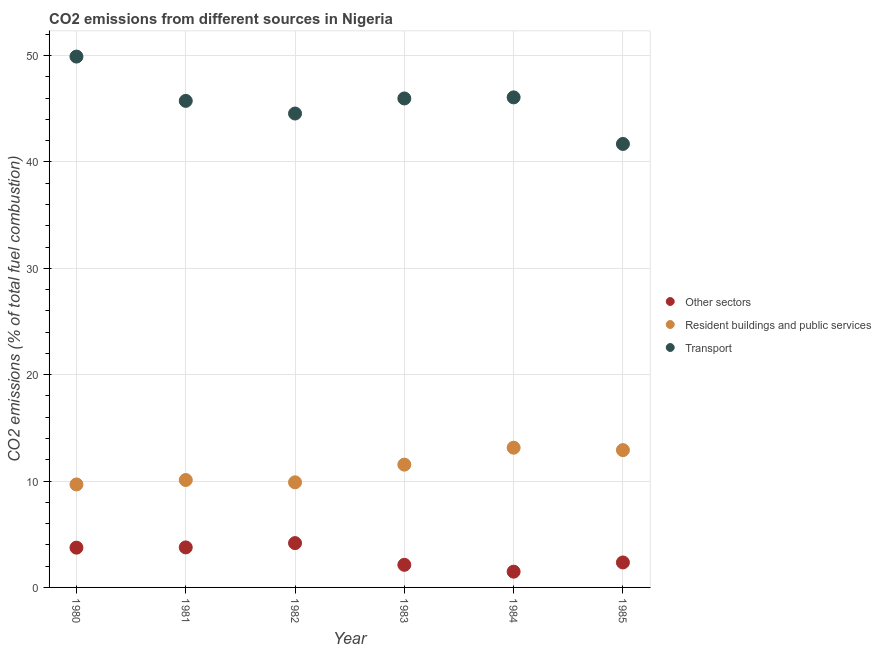How many different coloured dotlines are there?
Ensure brevity in your answer.  3. What is the percentage of co2 emissions from transport in 1980?
Offer a very short reply. 49.91. Across all years, what is the maximum percentage of co2 emissions from resident buildings and public services?
Make the answer very short. 13.14. Across all years, what is the minimum percentage of co2 emissions from resident buildings and public services?
Provide a short and direct response. 9.68. In which year was the percentage of co2 emissions from resident buildings and public services minimum?
Offer a terse response. 1980. What is the total percentage of co2 emissions from resident buildings and public services in the graph?
Give a very brief answer. 67.25. What is the difference between the percentage of co2 emissions from resident buildings and public services in 1982 and that in 1983?
Your answer should be very brief. -1.66. What is the difference between the percentage of co2 emissions from resident buildings and public services in 1982 and the percentage of co2 emissions from transport in 1984?
Provide a short and direct response. -36.19. What is the average percentage of co2 emissions from resident buildings and public services per year?
Provide a succinct answer. 11.21. In the year 1983, what is the difference between the percentage of co2 emissions from transport and percentage of co2 emissions from other sectors?
Keep it short and to the point. 43.84. What is the ratio of the percentage of co2 emissions from resident buildings and public services in 1981 to that in 1983?
Your response must be concise. 0.87. Is the percentage of co2 emissions from resident buildings and public services in 1984 less than that in 1985?
Offer a very short reply. No. Is the difference between the percentage of co2 emissions from transport in 1981 and 1982 greater than the difference between the percentage of co2 emissions from other sectors in 1981 and 1982?
Provide a short and direct response. Yes. What is the difference between the highest and the second highest percentage of co2 emissions from resident buildings and public services?
Your answer should be compact. 0.23. What is the difference between the highest and the lowest percentage of co2 emissions from transport?
Offer a terse response. 8.21. Is the percentage of co2 emissions from resident buildings and public services strictly less than the percentage of co2 emissions from transport over the years?
Your answer should be compact. Yes. How many dotlines are there?
Give a very brief answer. 3. How many years are there in the graph?
Your response must be concise. 6. How are the legend labels stacked?
Ensure brevity in your answer.  Vertical. What is the title of the graph?
Keep it short and to the point. CO2 emissions from different sources in Nigeria. Does "Nuclear sources" appear as one of the legend labels in the graph?
Give a very brief answer. No. What is the label or title of the X-axis?
Give a very brief answer. Year. What is the label or title of the Y-axis?
Make the answer very short. CO2 emissions (% of total fuel combustion). What is the CO2 emissions (% of total fuel combustion) of Other sectors in 1980?
Your answer should be very brief. 3.74. What is the CO2 emissions (% of total fuel combustion) in Resident buildings and public services in 1980?
Provide a short and direct response. 9.68. What is the CO2 emissions (% of total fuel combustion) of Transport in 1980?
Offer a very short reply. 49.91. What is the CO2 emissions (% of total fuel combustion) of Other sectors in 1981?
Your answer should be very brief. 3.76. What is the CO2 emissions (% of total fuel combustion) in Resident buildings and public services in 1981?
Make the answer very short. 10.1. What is the CO2 emissions (% of total fuel combustion) of Transport in 1981?
Provide a succinct answer. 45.74. What is the CO2 emissions (% of total fuel combustion) in Other sectors in 1982?
Keep it short and to the point. 4.17. What is the CO2 emissions (% of total fuel combustion) in Resident buildings and public services in 1982?
Your response must be concise. 9.88. What is the CO2 emissions (% of total fuel combustion) of Transport in 1982?
Offer a very short reply. 44.55. What is the CO2 emissions (% of total fuel combustion) in Other sectors in 1983?
Make the answer very short. 2.13. What is the CO2 emissions (% of total fuel combustion) of Resident buildings and public services in 1983?
Your answer should be very brief. 11.54. What is the CO2 emissions (% of total fuel combustion) of Transport in 1983?
Your answer should be very brief. 45.97. What is the CO2 emissions (% of total fuel combustion) of Other sectors in 1984?
Keep it short and to the point. 1.48. What is the CO2 emissions (% of total fuel combustion) of Resident buildings and public services in 1984?
Keep it short and to the point. 13.14. What is the CO2 emissions (% of total fuel combustion) of Transport in 1984?
Give a very brief answer. 46.07. What is the CO2 emissions (% of total fuel combustion) of Other sectors in 1985?
Your response must be concise. 2.35. What is the CO2 emissions (% of total fuel combustion) in Resident buildings and public services in 1985?
Offer a very short reply. 12.91. What is the CO2 emissions (% of total fuel combustion) of Transport in 1985?
Your answer should be very brief. 41.69. Across all years, what is the maximum CO2 emissions (% of total fuel combustion) in Other sectors?
Your answer should be very brief. 4.17. Across all years, what is the maximum CO2 emissions (% of total fuel combustion) of Resident buildings and public services?
Keep it short and to the point. 13.14. Across all years, what is the maximum CO2 emissions (% of total fuel combustion) in Transport?
Ensure brevity in your answer.  49.91. Across all years, what is the minimum CO2 emissions (% of total fuel combustion) in Other sectors?
Your response must be concise. 1.48. Across all years, what is the minimum CO2 emissions (% of total fuel combustion) of Resident buildings and public services?
Your answer should be compact. 9.68. Across all years, what is the minimum CO2 emissions (% of total fuel combustion) of Transport?
Offer a very short reply. 41.69. What is the total CO2 emissions (% of total fuel combustion) in Other sectors in the graph?
Offer a very short reply. 17.62. What is the total CO2 emissions (% of total fuel combustion) of Resident buildings and public services in the graph?
Provide a succinct answer. 67.25. What is the total CO2 emissions (% of total fuel combustion) of Transport in the graph?
Your response must be concise. 273.94. What is the difference between the CO2 emissions (% of total fuel combustion) in Other sectors in 1980 and that in 1981?
Your answer should be very brief. -0.02. What is the difference between the CO2 emissions (% of total fuel combustion) in Resident buildings and public services in 1980 and that in 1981?
Provide a short and direct response. -0.42. What is the difference between the CO2 emissions (% of total fuel combustion) in Transport in 1980 and that in 1981?
Your response must be concise. 4.16. What is the difference between the CO2 emissions (% of total fuel combustion) of Other sectors in 1980 and that in 1982?
Keep it short and to the point. -0.43. What is the difference between the CO2 emissions (% of total fuel combustion) in Resident buildings and public services in 1980 and that in 1982?
Make the answer very short. -0.2. What is the difference between the CO2 emissions (% of total fuel combustion) in Transport in 1980 and that in 1982?
Provide a short and direct response. 5.35. What is the difference between the CO2 emissions (% of total fuel combustion) in Other sectors in 1980 and that in 1983?
Provide a succinct answer. 1.61. What is the difference between the CO2 emissions (% of total fuel combustion) of Resident buildings and public services in 1980 and that in 1983?
Keep it short and to the point. -1.86. What is the difference between the CO2 emissions (% of total fuel combustion) of Transport in 1980 and that in 1983?
Make the answer very short. 3.94. What is the difference between the CO2 emissions (% of total fuel combustion) of Other sectors in 1980 and that in 1984?
Provide a short and direct response. 2.26. What is the difference between the CO2 emissions (% of total fuel combustion) in Resident buildings and public services in 1980 and that in 1984?
Keep it short and to the point. -3.45. What is the difference between the CO2 emissions (% of total fuel combustion) of Transport in 1980 and that in 1984?
Keep it short and to the point. 3.83. What is the difference between the CO2 emissions (% of total fuel combustion) in Other sectors in 1980 and that in 1985?
Provide a succinct answer. 1.39. What is the difference between the CO2 emissions (% of total fuel combustion) in Resident buildings and public services in 1980 and that in 1985?
Ensure brevity in your answer.  -3.23. What is the difference between the CO2 emissions (% of total fuel combustion) of Transport in 1980 and that in 1985?
Ensure brevity in your answer.  8.21. What is the difference between the CO2 emissions (% of total fuel combustion) of Other sectors in 1981 and that in 1982?
Your answer should be very brief. -0.4. What is the difference between the CO2 emissions (% of total fuel combustion) of Resident buildings and public services in 1981 and that in 1982?
Provide a succinct answer. 0.22. What is the difference between the CO2 emissions (% of total fuel combustion) of Transport in 1981 and that in 1982?
Ensure brevity in your answer.  1.19. What is the difference between the CO2 emissions (% of total fuel combustion) in Other sectors in 1981 and that in 1983?
Provide a succinct answer. 1.64. What is the difference between the CO2 emissions (% of total fuel combustion) in Resident buildings and public services in 1981 and that in 1983?
Offer a terse response. -1.45. What is the difference between the CO2 emissions (% of total fuel combustion) in Transport in 1981 and that in 1983?
Keep it short and to the point. -0.23. What is the difference between the CO2 emissions (% of total fuel combustion) of Other sectors in 1981 and that in 1984?
Offer a very short reply. 2.28. What is the difference between the CO2 emissions (% of total fuel combustion) in Resident buildings and public services in 1981 and that in 1984?
Your answer should be very brief. -3.04. What is the difference between the CO2 emissions (% of total fuel combustion) in Transport in 1981 and that in 1984?
Offer a terse response. -0.33. What is the difference between the CO2 emissions (% of total fuel combustion) of Other sectors in 1981 and that in 1985?
Offer a very short reply. 1.42. What is the difference between the CO2 emissions (% of total fuel combustion) of Resident buildings and public services in 1981 and that in 1985?
Give a very brief answer. -2.81. What is the difference between the CO2 emissions (% of total fuel combustion) in Transport in 1981 and that in 1985?
Your response must be concise. 4.05. What is the difference between the CO2 emissions (% of total fuel combustion) of Other sectors in 1982 and that in 1983?
Make the answer very short. 2.04. What is the difference between the CO2 emissions (% of total fuel combustion) in Resident buildings and public services in 1982 and that in 1983?
Give a very brief answer. -1.66. What is the difference between the CO2 emissions (% of total fuel combustion) of Transport in 1982 and that in 1983?
Offer a terse response. -1.42. What is the difference between the CO2 emissions (% of total fuel combustion) of Other sectors in 1982 and that in 1984?
Ensure brevity in your answer.  2.69. What is the difference between the CO2 emissions (% of total fuel combustion) of Resident buildings and public services in 1982 and that in 1984?
Make the answer very short. -3.25. What is the difference between the CO2 emissions (% of total fuel combustion) in Transport in 1982 and that in 1984?
Your response must be concise. -1.52. What is the difference between the CO2 emissions (% of total fuel combustion) in Other sectors in 1982 and that in 1985?
Provide a succinct answer. 1.82. What is the difference between the CO2 emissions (% of total fuel combustion) in Resident buildings and public services in 1982 and that in 1985?
Offer a terse response. -3.03. What is the difference between the CO2 emissions (% of total fuel combustion) of Transport in 1982 and that in 1985?
Offer a terse response. 2.86. What is the difference between the CO2 emissions (% of total fuel combustion) of Other sectors in 1983 and that in 1984?
Provide a succinct answer. 0.64. What is the difference between the CO2 emissions (% of total fuel combustion) of Resident buildings and public services in 1983 and that in 1984?
Offer a very short reply. -1.59. What is the difference between the CO2 emissions (% of total fuel combustion) of Transport in 1983 and that in 1984?
Provide a succinct answer. -0.1. What is the difference between the CO2 emissions (% of total fuel combustion) of Other sectors in 1983 and that in 1985?
Ensure brevity in your answer.  -0.22. What is the difference between the CO2 emissions (% of total fuel combustion) of Resident buildings and public services in 1983 and that in 1985?
Your answer should be compact. -1.37. What is the difference between the CO2 emissions (% of total fuel combustion) of Transport in 1983 and that in 1985?
Make the answer very short. 4.28. What is the difference between the CO2 emissions (% of total fuel combustion) of Other sectors in 1984 and that in 1985?
Give a very brief answer. -0.87. What is the difference between the CO2 emissions (% of total fuel combustion) of Resident buildings and public services in 1984 and that in 1985?
Provide a short and direct response. 0.23. What is the difference between the CO2 emissions (% of total fuel combustion) in Transport in 1984 and that in 1985?
Provide a succinct answer. 4.38. What is the difference between the CO2 emissions (% of total fuel combustion) of Other sectors in 1980 and the CO2 emissions (% of total fuel combustion) of Resident buildings and public services in 1981?
Give a very brief answer. -6.36. What is the difference between the CO2 emissions (% of total fuel combustion) of Other sectors in 1980 and the CO2 emissions (% of total fuel combustion) of Transport in 1981?
Your answer should be very brief. -42. What is the difference between the CO2 emissions (% of total fuel combustion) of Resident buildings and public services in 1980 and the CO2 emissions (% of total fuel combustion) of Transport in 1981?
Make the answer very short. -36.06. What is the difference between the CO2 emissions (% of total fuel combustion) in Other sectors in 1980 and the CO2 emissions (% of total fuel combustion) in Resident buildings and public services in 1982?
Keep it short and to the point. -6.14. What is the difference between the CO2 emissions (% of total fuel combustion) in Other sectors in 1980 and the CO2 emissions (% of total fuel combustion) in Transport in 1982?
Provide a succinct answer. -40.82. What is the difference between the CO2 emissions (% of total fuel combustion) of Resident buildings and public services in 1980 and the CO2 emissions (% of total fuel combustion) of Transport in 1982?
Provide a succinct answer. -34.87. What is the difference between the CO2 emissions (% of total fuel combustion) in Other sectors in 1980 and the CO2 emissions (% of total fuel combustion) in Resident buildings and public services in 1983?
Keep it short and to the point. -7.81. What is the difference between the CO2 emissions (% of total fuel combustion) of Other sectors in 1980 and the CO2 emissions (% of total fuel combustion) of Transport in 1983?
Your answer should be very brief. -42.23. What is the difference between the CO2 emissions (% of total fuel combustion) in Resident buildings and public services in 1980 and the CO2 emissions (% of total fuel combustion) in Transport in 1983?
Give a very brief answer. -36.29. What is the difference between the CO2 emissions (% of total fuel combustion) in Other sectors in 1980 and the CO2 emissions (% of total fuel combustion) in Resident buildings and public services in 1984?
Your response must be concise. -9.4. What is the difference between the CO2 emissions (% of total fuel combustion) in Other sectors in 1980 and the CO2 emissions (% of total fuel combustion) in Transport in 1984?
Offer a very short reply. -42.33. What is the difference between the CO2 emissions (% of total fuel combustion) of Resident buildings and public services in 1980 and the CO2 emissions (% of total fuel combustion) of Transport in 1984?
Offer a very short reply. -36.39. What is the difference between the CO2 emissions (% of total fuel combustion) in Other sectors in 1980 and the CO2 emissions (% of total fuel combustion) in Resident buildings and public services in 1985?
Your answer should be compact. -9.17. What is the difference between the CO2 emissions (% of total fuel combustion) in Other sectors in 1980 and the CO2 emissions (% of total fuel combustion) in Transport in 1985?
Your answer should be compact. -37.95. What is the difference between the CO2 emissions (% of total fuel combustion) in Resident buildings and public services in 1980 and the CO2 emissions (% of total fuel combustion) in Transport in 1985?
Give a very brief answer. -32.01. What is the difference between the CO2 emissions (% of total fuel combustion) in Other sectors in 1981 and the CO2 emissions (% of total fuel combustion) in Resident buildings and public services in 1982?
Your response must be concise. -6.12. What is the difference between the CO2 emissions (% of total fuel combustion) of Other sectors in 1981 and the CO2 emissions (% of total fuel combustion) of Transport in 1982?
Your answer should be very brief. -40.79. What is the difference between the CO2 emissions (% of total fuel combustion) of Resident buildings and public services in 1981 and the CO2 emissions (% of total fuel combustion) of Transport in 1982?
Your answer should be very brief. -34.45. What is the difference between the CO2 emissions (% of total fuel combustion) in Other sectors in 1981 and the CO2 emissions (% of total fuel combustion) in Resident buildings and public services in 1983?
Give a very brief answer. -7.78. What is the difference between the CO2 emissions (% of total fuel combustion) in Other sectors in 1981 and the CO2 emissions (% of total fuel combustion) in Transport in 1983?
Your answer should be very brief. -42.21. What is the difference between the CO2 emissions (% of total fuel combustion) of Resident buildings and public services in 1981 and the CO2 emissions (% of total fuel combustion) of Transport in 1983?
Offer a terse response. -35.87. What is the difference between the CO2 emissions (% of total fuel combustion) in Other sectors in 1981 and the CO2 emissions (% of total fuel combustion) in Resident buildings and public services in 1984?
Provide a succinct answer. -9.37. What is the difference between the CO2 emissions (% of total fuel combustion) in Other sectors in 1981 and the CO2 emissions (% of total fuel combustion) in Transport in 1984?
Make the answer very short. -42.31. What is the difference between the CO2 emissions (% of total fuel combustion) in Resident buildings and public services in 1981 and the CO2 emissions (% of total fuel combustion) in Transport in 1984?
Provide a succinct answer. -35.97. What is the difference between the CO2 emissions (% of total fuel combustion) in Other sectors in 1981 and the CO2 emissions (% of total fuel combustion) in Resident buildings and public services in 1985?
Your answer should be compact. -9.15. What is the difference between the CO2 emissions (% of total fuel combustion) in Other sectors in 1981 and the CO2 emissions (% of total fuel combustion) in Transport in 1985?
Your response must be concise. -37.93. What is the difference between the CO2 emissions (% of total fuel combustion) of Resident buildings and public services in 1981 and the CO2 emissions (% of total fuel combustion) of Transport in 1985?
Your answer should be very brief. -31.59. What is the difference between the CO2 emissions (% of total fuel combustion) in Other sectors in 1982 and the CO2 emissions (% of total fuel combustion) in Resident buildings and public services in 1983?
Your response must be concise. -7.38. What is the difference between the CO2 emissions (% of total fuel combustion) in Other sectors in 1982 and the CO2 emissions (% of total fuel combustion) in Transport in 1983?
Give a very brief answer. -41.8. What is the difference between the CO2 emissions (% of total fuel combustion) of Resident buildings and public services in 1982 and the CO2 emissions (% of total fuel combustion) of Transport in 1983?
Your response must be concise. -36.09. What is the difference between the CO2 emissions (% of total fuel combustion) of Other sectors in 1982 and the CO2 emissions (% of total fuel combustion) of Resident buildings and public services in 1984?
Your answer should be very brief. -8.97. What is the difference between the CO2 emissions (% of total fuel combustion) in Other sectors in 1982 and the CO2 emissions (% of total fuel combustion) in Transport in 1984?
Provide a succinct answer. -41.91. What is the difference between the CO2 emissions (% of total fuel combustion) in Resident buildings and public services in 1982 and the CO2 emissions (% of total fuel combustion) in Transport in 1984?
Provide a short and direct response. -36.19. What is the difference between the CO2 emissions (% of total fuel combustion) in Other sectors in 1982 and the CO2 emissions (% of total fuel combustion) in Resident buildings and public services in 1985?
Make the answer very short. -8.74. What is the difference between the CO2 emissions (% of total fuel combustion) in Other sectors in 1982 and the CO2 emissions (% of total fuel combustion) in Transport in 1985?
Make the answer very short. -37.53. What is the difference between the CO2 emissions (% of total fuel combustion) of Resident buildings and public services in 1982 and the CO2 emissions (% of total fuel combustion) of Transport in 1985?
Give a very brief answer. -31.81. What is the difference between the CO2 emissions (% of total fuel combustion) in Other sectors in 1983 and the CO2 emissions (% of total fuel combustion) in Resident buildings and public services in 1984?
Your answer should be compact. -11.01. What is the difference between the CO2 emissions (% of total fuel combustion) of Other sectors in 1983 and the CO2 emissions (% of total fuel combustion) of Transport in 1984?
Your answer should be compact. -43.95. What is the difference between the CO2 emissions (% of total fuel combustion) of Resident buildings and public services in 1983 and the CO2 emissions (% of total fuel combustion) of Transport in 1984?
Make the answer very short. -34.53. What is the difference between the CO2 emissions (% of total fuel combustion) in Other sectors in 1983 and the CO2 emissions (% of total fuel combustion) in Resident buildings and public services in 1985?
Give a very brief answer. -10.78. What is the difference between the CO2 emissions (% of total fuel combustion) of Other sectors in 1983 and the CO2 emissions (% of total fuel combustion) of Transport in 1985?
Make the answer very short. -39.57. What is the difference between the CO2 emissions (% of total fuel combustion) of Resident buildings and public services in 1983 and the CO2 emissions (% of total fuel combustion) of Transport in 1985?
Provide a succinct answer. -30.15. What is the difference between the CO2 emissions (% of total fuel combustion) of Other sectors in 1984 and the CO2 emissions (% of total fuel combustion) of Resident buildings and public services in 1985?
Offer a terse response. -11.43. What is the difference between the CO2 emissions (% of total fuel combustion) in Other sectors in 1984 and the CO2 emissions (% of total fuel combustion) in Transport in 1985?
Your response must be concise. -40.21. What is the difference between the CO2 emissions (% of total fuel combustion) of Resident buildings and public services in 1984 and the CO2 emissions (% of total fuel combustion) of Transport in 1985?
Provide a short and direct response. -28.56. What is the average CO2 emissions (% of total fuel combustion) in Other sectors per year?
Your answer should be very brief. 2.94. What is the average CO2 emissions (% of total fuel combustion) of Resident buildings and public services per year?
Your answer should be compact. 11.21. What is the average CO2 emissions (% of total fuel combustion) of Transport per year?
Offer a terse response. 45.66. In the year 1980, what is the difference between the CO2 emissions (% of total fuel combustion) of Other sectors and CO2 emissions (% of total fuel combustion) of Resident buildings and public services?
Ensure brevity in your answer.  -5.94. In the year 1980, what is the difference between the CO2 emissions (% of total fuel combustion) of Other sectors and CO2 emissions (% of total fuel combustion) of Transport?
Make the answer very short. -46.17. In the year 1980, what is the difference between the CO2 emissions (% of total fuel combustion) in Resident buildings and public services and CO2 emissions (% of total fuel combustion) in Transport?
Your answer should be very brief. -40.22. In the year 1981, what is the difference between the CO2 emissions (% of total fuel combustion) of Other sectors and CO2 emissions (% of total fuel combustion) of Resident buildings and public services?
Provide a short and direct response. -6.34. In the year 1981, what is the difference between the CO2 emissions (% of total fuel combustion) of Other sectors and CO2 emissions (% of total fuel combustion) of Transport?
Your answer should be compact. -41.98. In the year 1981, what is the difference between the CO2 emissions (% of total fuel combustion) in Resident buildings and public services and CO2 emissions (% of total fuel combustion) in Transport?
Offer a very short reply. -35.64. In the year 1982, what is the difference between the CO2 emissions (% of total fuel combustion) of Other sectors and CO2 emissions (% of total fuel combustion) of Resident buildings and public services?
Ensure brevity in your answer.  -5.71. In the year 1982, what is the difference between the CO2 emissions (% of total fuel combustion) in Other sectors and CO2 emissions (% of total fuel combustion) in Transport?
Your answer should be compact. -40.39. In the year 1982, what is the difference between the CO2 emissions (% of total fuel combustion) in Resident buildings and public services and CO2 emissions (% of total fuel combustion) in Transport?
Your response must be concise. -34.67. In the year 1983, what is the difference between the CO2 emissions (% of total fuel combustion) of Other sectors and CO2 emissions (% of total fuel combustion) of Resident buildings and public services?
Make the answer very short. -9.42. In the year 1983, what is the difference between the CO2 emissions (% of total fuel combustion) in Other sectors and CO2 emissions (% of total fuel combustion) in Transport?
Your response must be concise. -43.84. In the year 1983, what is the difference between the CO2 emissions (% of total fuel combustion) of Resident buildings and public services and CO2 emissions (% of total fuel combustion) of Transport?
Your answer should be very brief. -34.43. In the year 1984, what is the difference between the CO2 emissions (% of total fuel combustion) in Other sectors and CO2 emissions (% of total fuel combustion) in Resident buildings and public services?
Provide a short and direct response. -11.65. In the year 1984, what is the difference between the CO2 emissions (% of total fuel combustion) of Other sectors and CO2 emissions (% of total fuel combustion) of Transport?
Offer a terse response. -44.59. In the year 1984, what is the difference between the CO2 emissions (% of total fuel combustion) of Resident buildings and public services and CO2 emissions (% of total fuel combustion) of Transport?
Offer a very short reply. -32.94. In the year 1985, what is the difference between the CO2 emissions (% of total fuel combustion) of Other sectors and CO2 emissions (% of total fuel combustion) of Resident buildings and public services?
Your answer should be compact. -10.56. In the year 1985, what is the difference between the CO2 emissions (% of total fuel combustion) of Other sectors and CO2 emissions (% of total fuel combustion) of Transport?
Your answer should be compact. -39.35. In the year 1985, what is the difference between the CO2 emissions (% of total fuel combustion) of Resident buildings and public services and CO2 emissions (% of total fuel combustion) of Transport?
Offer a very short reply. -28.78. What is the ratio of the CO2 emissions (% of total fuel combustion) in Other sectors in 1980 to that in 1981?
Your response must be concise. 0.99. What is the ratio of the CO2 emissions (% of total fuel combustion) of Resident buildings and public services in 1980 to that in 1981?
Provide a succinct answer. 0.96. What is the ratio of the CO2 emissions (% of total fuel combustion) of Transport in 1980 to that in 1981?
Give a very brief answer. 1.09. What is the ratio of the CO2 emissions (% of total fuel combustion) in Other sectors in 1980 to that in 1982?
Offer a very short reply. 0.9. What is the ratio of the CO2 emissions (% of total fuel combustion) of Resident buildings and public services in 1980 to that in 1982?
Offer a very short reply. 0.98. What is the ratio of the CO2 emissions (% of total fuel combustion) of Transport in 1980 to that in 1982?
Your answer should be compact. 1.12. What is the ratio of the CO2 emissions (% of total fuel combustion) of Other sectors in 1980 to that in 1983?
Ensure brevity in your answer.  1.76. What is the ratio of the CO2 emissions (% of total fuel combustion) in Resident buildings and public services in 1980 to that in 1983?
Your answer should be very brief. 0.84. What is the ratio of the CO2 emissions (% of total fuel combustion) in Transport in 1980 to that in 1983?
Keep it short and to the point. 1.09. What is the ratio of the CO2 emissions (% of total fuel combustion) in Other sectors in 1980 to that in 1984?
Ensure brevity in your answer.  2.52. What is the ratio of the CO2 emissions (% of total fuel combustion) in Resident buildings and public services in 1980 to that in 1984?
Provide a succinct answer. 0.74. What is the ratio of the CO2 emissions (% of total fuel combustion) of Transport in 1980 to that in 1984?
Make the answer very short. 1.08. What is the ratio of the CO2 emissions (% of total fuel combustion) of Other sectors in 1980 to that in 1985?
Offer a terse response. 1.59. What is the ratio of the CO2 emissions (% of total fuel combustion) in Transport in 1980 to that in 1985?
Give a very brief answer. 1.2. What is the ratio of the CO2 emissions (% of total fuel combustion) of Other sectors in 1981 to that in 1982?
Provide a short and direct response. 0.9. What is the ratio of the CO2 emissions (% of total fuel combustion) of Resident buildings and public services in 1981 to that in 1982?
Ensure brevity in your answer.  1.02. What is the ratio of the CO2 emissions (% of total fuel combustion) of Transport in 1981 to that in 1982?
Offer a terse response. 1.03. What is the ratio of the CO2 emissions (% of total fuel combustion) of Other sectors in 1981 to that in 1983?
Keep it short and to the point. 1.77. What is the ratio of the CO2 emissions (% of total fuel combustion) in Resident buildings and public services in 1981 to that in 1983?
Provide a short and direct response. 0.87. What is the ratio of the CO2 emissions (% of total fuel combustion) in Transport in 1981 to that in 1983?
Offer a very short reply. 1. What is the ratio of the CO2 emissions (% of total fuel combustion) in Other sectors in 1981 to that in 1984?
Your answer should be compact. 2.54. What is the ratio of the CO2 emissions (% of total fuel combustion) in Resident buildings and public services in 1981 to that in 1984?
Your answer should be compact. 0.77. What is the ratio of the CO2 emissions (% of total fuel combustion) of Transport in 1981 to that in 1984?
Ensure brevity in your answer.  0.99. What is the ratio of the CO2 emissions (% of total fuel combustion) in Other sectors in 1981 to that in 1985?
Offer a very short reply. 1.6. What is the ratio of the CO2 emissions (% of total fuel combustion) in Resident buildings and public services in 1981 to that in 1985?
Your answer should be very brief. 0.78. What is the ratio of the CO2 emissions (% of total fuel combustion) in Transport in 1981 to that in 1985?
Your response must be concise. 1.1. What is the ratio of the CO2 emissions (% of total fuel combustion) of Other sectors in 1982 to that in 1983?
Your answer should be compact. 1.96. What is the ratio of the CO2 emissions (% of total fuel combustion) of Resident buildings and public services in 1982 to that in 1983?
Ensure brevity in your answer.  0.86. What is the ratio of the CO2 emissions (% of total fuel combustion) of Transport in 1982 to that in 1983?
Your response must be concise. 0.97. What is the ratio of the CO2 emissions (% of total fuel combustion) of Other sectors in 1982 to that in 1984?
Give a very brief answer. 2.81. What is the ratio of the CO2 emissions (% of total fuel combustion) of Resident buildings and public services in 1982 to that in 1984?
Ensure brevity in your answer.  0.75. What is the ratio of the CO2 emissions (% of total fuel combustion) in Other sectors in 1982 to that in 1985?
Offer a very short reply. 1.78. What is the ratio of the CO2 emissions (% of total fuel combustion) in Resident buildings and public services in 1982 to that in 1985?
Your answer should be very brief. 0.77. What is the ratio of the CO2 emissions (% of total fuel combustion) of Transport in 1982 to that in 1985?
Your response must be concise. 1.07. What is the ratio of the CO2 emissions (% of total fuel combustion) in Other sectors in 1983 to that in 1984?
Ensure brevity in your answer.  1.44. What is the ratio of the CO2 emissions (% of total fuel combustion) of Resident buildings and public services in 1983 to that in 1984?
Your answer should be compact. 0.88. What is the ratio of the CO2 emissions (% of total fuel combustion) of Other sectors in 1983 to that in 1985?
Your answer should be compact. 0.91. What is the ratio of the CO2 emissions (% of total fuel combustion) in Resident buildings and public services in 1983 to that in 1985?
Provide a succinct answer. 0.89. What is the ratio of the CO2 emissions (% of total fuel combustion) of Transport in 1983 to that in 1985?
Make the answer very short. 1.1. What is the ratio of the CO2 emissions (% of total fuel combustion) of Other sectors in 1984 to that in 1985?
Make the answer very short. 0.63. What is the ratio of the CO2 emissions (% of total fuel combustion) in Resident buildings and public services in 1984 to that in 1985?
Offer a terse response. 1.02. What is the ratio of the CO2 emissions (% of total fuel combustion) in Transport in 1984 to that in 1985?
Offer a terse response. 1.1. What is the difference between the highest and the second highest CO2 emissions (% of total fuel combustion) in Other sectors?
Offer a very short reply. 0.4. What is the difference between the highest and the second highest CO2 emissions (% of total fuel combustion) in Resident buildings and public services?
Provide a short and direct response. 0.23. What is the difference between the highest and the second highest CO2 emissions (% of total fuel combustion) in Transport?
Ensure brevity in your answer.  3.83. What is the difference between the highest and the lowest CO2 emissions (% of total fuel combustion) in Other sectors?
Your answer should be very brief. 2.69. What is the difference between the highest and the lowest CO2 emissions (% of total fuel combustion) of Resident buildings and public services?
Your answer should be very brief. 3.45. What is the difference between the highest and the lowest CO2 emissions (% of total fuel combustion) in Transport?
Offer a terse response. 8.21. 